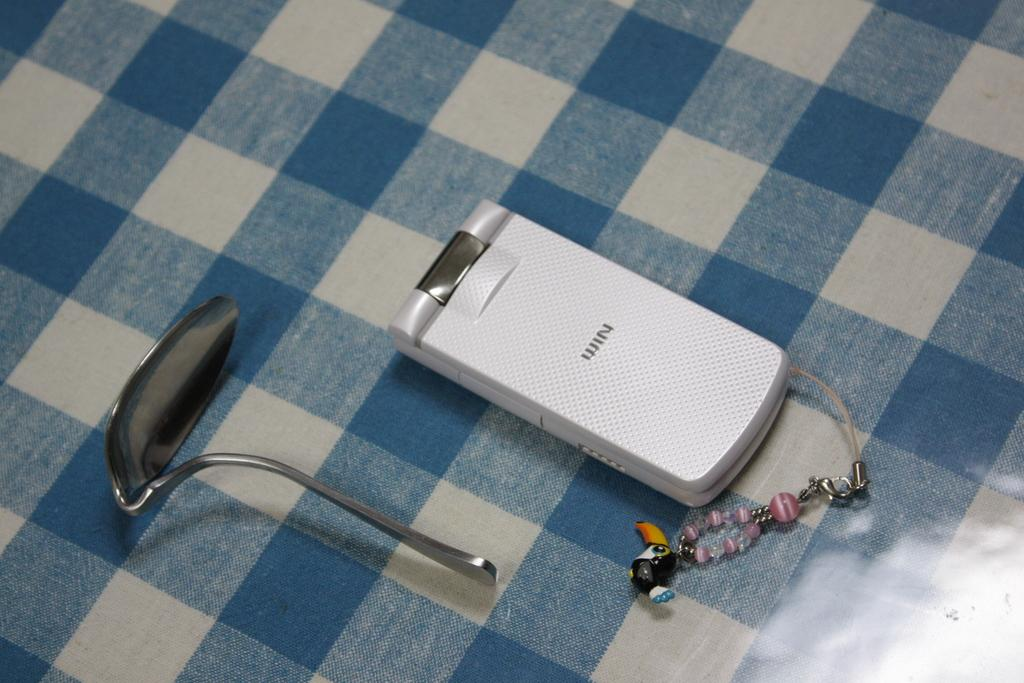What electronic device is visible in the image? There is a mobile phone in the image. What is attached to the mobile phone? There is a key chain with the mobile phone. What utensil can be seen in the image? There is a bent spoon in the image. On what is the bent spoon placed? The bent spoon is placed on a cloth. What colors are present on the cloth? The cloth has blue and white colors. What type of treatment is being administered to the mint plant in the image? There is no mint plant present in the image, so no treatment is being administered. 